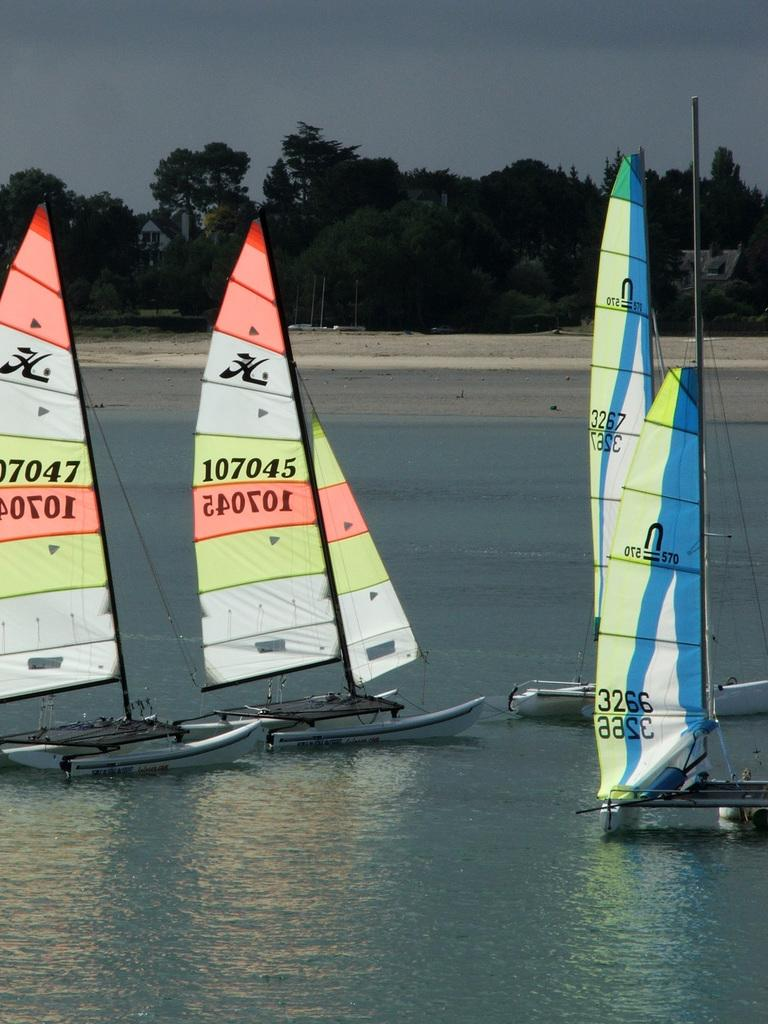<image>
Create a compact narrative representing the image presented. Sailboats with number 107045 and 107047 are in the water. 